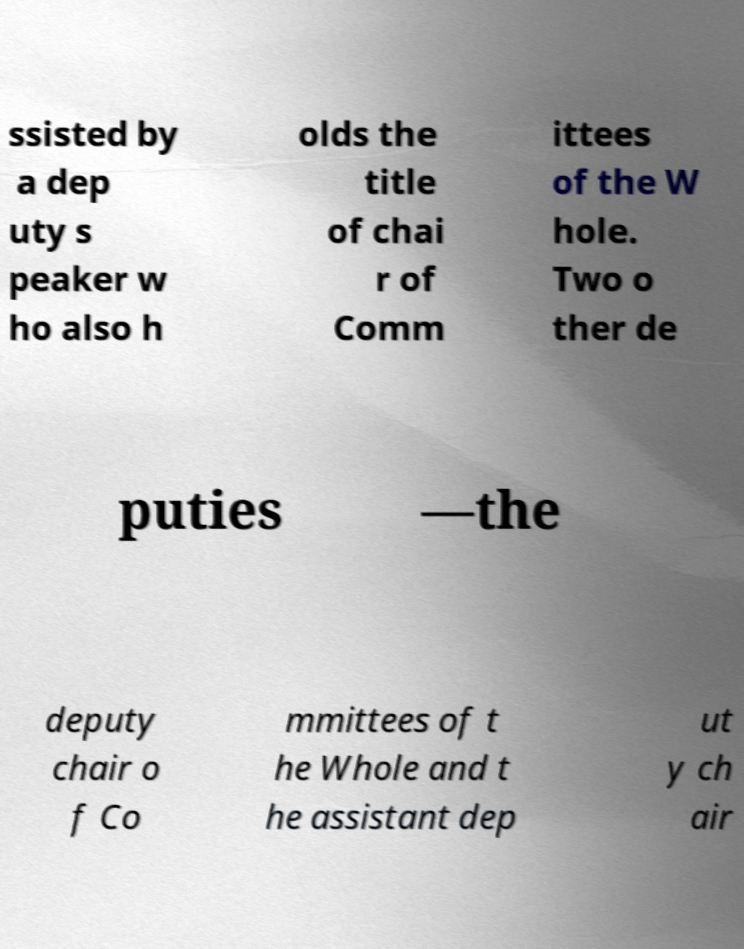Can you accurately transcribe the text from the provided image for me? ssisted by a dep uty s peaker w ho also h olds the title of chai r of Comm ittees of the W hole. Two o ther de puties —the deputy chair o f Co mmittees of t he Whole and t he assistant dep ut y ch air 